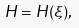Convert formula to latex. <formula><loc_0><loc_0><loc_500><loc_500>H = H ( \xi ) ,</formula> 